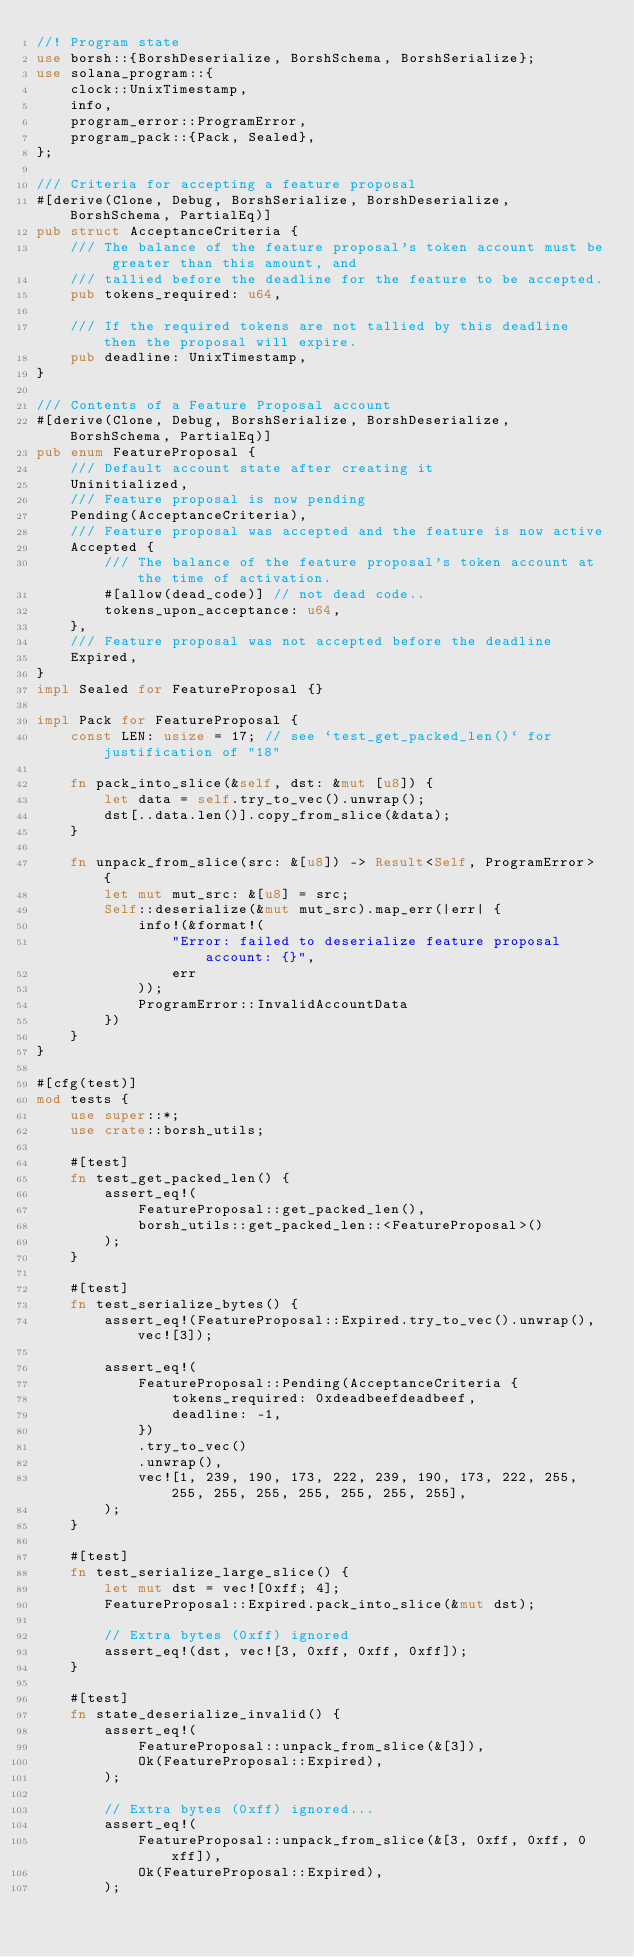<code> <loc_0><loc_0><loc_500><loc_500><_Rust_>//! Program state
use borsh::{BorshDeserialize, BorshSchema, BorshSerialize};
use solana_program::{
    clock::UnixTimestamp,
    info,
    program_error::ProgramError,
    program_pack::{Pack, Sealed},
};

/// Criteria for accepting a feature proposal
#[derive(Clone, Debug, BorshSerialize, BorshDeserialize, BorshSchema, PartialEq)]
pub struct AcceptanceCriteria {
    /// The balance of the feature proposal's token account must be greater than this amount, and
    /// tallied before the deadline for the feature to be accepted.
    pub tokens_required: u64,

    /// If the required tokens are not tallied by this deadline then the proposal will expire.
    pub deadline: UnixTimestamp,
}

/// Contents of a Feature Proposal account
#[derive(Clone, Debug, BorshSerialize, BorshDeserialize, BorshSchema, PartialEq)]
pub enum FeatureProposal {
    /// Default account state after creating it
    Uninitialized,
    /// Feature proposal is now pending
    Pending(AcceptanceCriteria),
    /// Feature proposal was accepted and the feature is now active
    Accepted {
        /// The balance of the feature proposal's token account at the time of activation.
        #[allow(dead_code)] // not dead code..
        tokens_upon_acceptance: u64,
    },
    /// Feature proposal was not accepted before the deadline
    Expired,
}
impl Sealed for FeatureProposal {}

impl Pack for FeatureProposal {
    const LEN: usize = 17; // see `test_get_packed_len()` for justification of "18"

    fn pack_into_slice(&self, dst: &mut [u8]) {
        let data = self.try_to_vec().unwrap();
        dst[..data.len()].copy_from_slice(&data);
    }

    fn unpack_from_slice(src: &[u8]) -> Result<Self, ProgramError> {
        let mut mut_src: &[u8] = src;
        Self::deserialize(&mut mut_src).map_err(|err| {
            info!(&format!(
                "Error: failed to deserialize feature proposal account: {}",
                err
            ));
            ProgramError::InvalidAccountData
        })
    }
}

#[cfg(test)]
mod tests {
    use super::*;
    use crate::borsh_utils;

    #[test]
    fn test_get_packed_len() {
        assert_eq!(
            FeatureProposal::get_packed_len(),
            borsh_utils::get_packed_len::<FeatureProposal>()
        );
    }

    #[test]
    fn test_serialize_bytes() {
        assert_eq!(FeatureProposal::Expired.try_to_vec().unwrap(), vec![3]);

        assert_eq!(
            FeatureProposal::Pending(AcceptanceCriteria {
                tokens_required: 0xdeadbeefdeadbeef,
                deadline: -1,
            })
            .try_to_vec()
            .unwrap(),
            vec![1, 239, 190, 173, 222, 239, 190, 173, 222, 255, 255, 255, 255, 255, 255, 255, 255],
        );
    }

    #[test]
    fn test_serialize_large_slice() {
        let mut dst = vec![0xff; 4];
        FeatureProposal::Expired.pack_into_slice(&mut dst);

        // Extra bytes (0xff) ignored
        assert_eq!(dst, vec![3, 0xff, 0xff, 0xff]);
    }

    #[test]
    fn state_deserialize_invalid() {
        assert_eq!(
            FeatureProposal::unpack_from_slice(&[3]),
            Ok(FeatureProposal::Expired),
        );

        // Extra bytes (0xff) ignored...
        assert_eq!(
            FeatureProposal::unpack_from_slice(&[3, 0xff, 0xff, 0xff]),
            Ok(FeatureProposal::Expired),
        );
</code> 